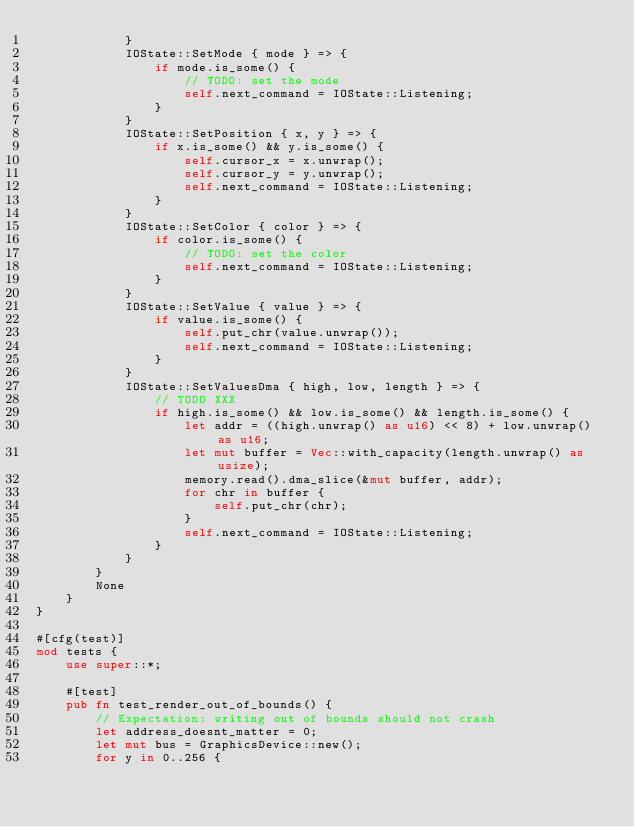Convert code to text. <code><loc_0><loc_0><loc_500><loc_500><_Rust_>            }
            IOState::SetMode { mode } => {
                if mode.is_some() {
                    // TODO: set the mode
                    self.next_command = IOState::Listening;
                }
            }
            IOState::SetPosition { x, y } => {
                if x.is_some() && y.is_some() {
                    self.cursor_x = x.unwrap();
                    self.cursor_y = y.unwrap();
                    self.next_command = IOState::Listening;
                }
            }
            IOState::SetColor { color } => {
                if color.is_some() {
                    // TODO: set the color
                    self.next_command = IOState::Listening;
                }
            }
            IOState::SetValue { value } => {
                if value.is_some() {
                    self.put_chr(value.unwrap());
                    self.next_command = IOState::Listening;
                }
            }
            IOState::SetValuesDma { high, low, length } => {
                // TODO XXX
                if high.is_some() && low.is_some() && length.is_some() {
                    let addr = ((high.unwrap() as u16) << 8) + low.unwrap() as u16;
                    let mut buffer = Vec::with_capacity(length.unwrap() as usize);
                    memory.read().dma_slice(&mut buffer, addr);
                    for chr in buffer {
                        self.put_chr(chr);
                    }
                    self.next_command = IOState::Listening;
                }
            }
        }
        None
    }
}

#[cfg(test)]
mod tests {
    use super::*;

    #[test]
    pub fn test_render_out_of_bounds() {
        // Expectation: writing out of bounds should not crash
        let address_doesnt_matter = 0;
        let mut bus = GraphicsDevice::new();
        for y in 0..256 {</code> 